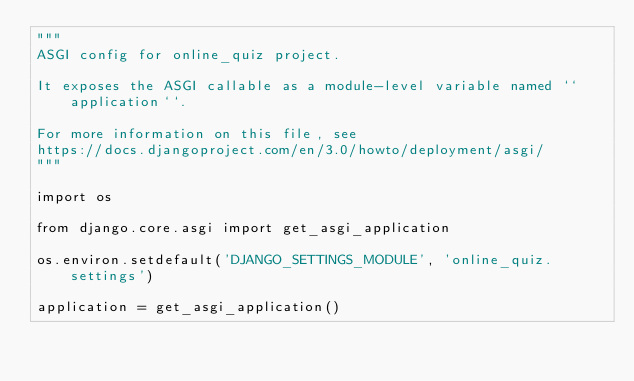Convert code to text. <code><loc_0><loc_0><loc_500><loc_500><_Python_>"""
ASGI config for online_quiz project.

It exposes the ASGI callable as a module-level variable named ``application``.

For more information on this file, see
https://docs.djangoproject.com/en/3.0/howto/deployment/asgi/
"""

import os

from django.core.asgi import get_asgi_application

os.environ.setdefault('DJANGO_SETTINGS_MODULE', 'online_quiz.settings')

application = get_asgi_application()
</code> 